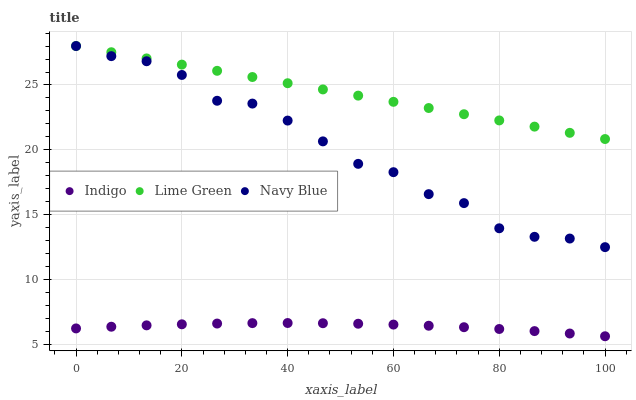Does Indigo have the minimum area under the curve?
Answer yes or no. Yes. Does Lime Green have the maximum area under the curve?
Answer yes or no. Yes. Does Navy Blue have the minimum area under the curve?
Answer yes or no. No. Does Navy Blue have the maximum area under the curve?
Answer yes or no. No. Is Lime Green the smoothest?
Answer yes or no. Yes. Is Navy Blue the roughest?
Answer yes or no. Yes. Is Indigo the smoothest?
Answer yes or no. No. Is Indigo the roughest?
Answer yes or no. No. Does Indigo have the lowest value?
Answer yes or no. Yes. Does Navy Blue have the lowest value?
Answer yes or no. No. Does Navy Blue have the highest value?
Answer yes or no. Yes. Does Indigo have the highest value?
Answer yes or no. No. Is Indigo less than Navy Blue?
Answer yes or no. Yes. Is Lime Green greater than Indigo?
Answer yes or no. Yes. Does Navy Blue intersect Lime Green?
Answer yes or no. Yes. Is Navy Blue less than Lime Green?
Answer yes or no. No. Is Navy Blue greater than Lime Green?
Answer yes or no. No. Does Indigo intersect Navy Blue?
Answer yes or no. No. 